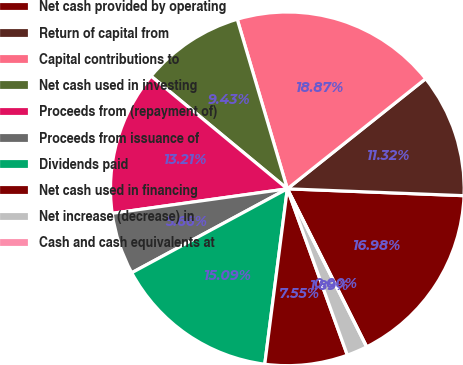<chart> <loc_0><loc_0><loc_500><loc_500><pie_chart><fcel>Net cash provided by operating<fcel>Return of capital from<fcel>Capital contributions to<fcel>Net cash used in investing<fcel>Proceeds from (repayment of)<fcel>Proceeds from issuance of<fcel>Dividends paid<fcel>Net cash used in financing<fcel>Net increase (decrease) in<fcel>Cash and cash equivalents at<nl><fcel>16.98%<fcel>11.32%<fcel>18.87%<fcel>9.43%<fcel>13.21%<fcel>5.66%<fcel>15.09%<fcel>7.55%<fcel>1.89%<fcel>0.0%<nl></chart> 